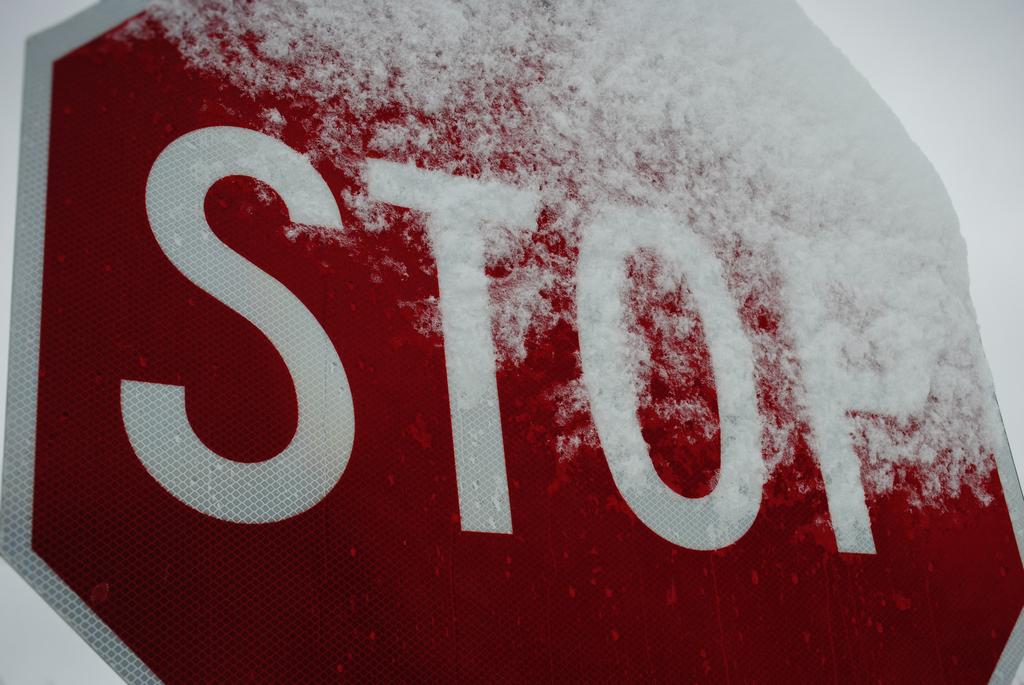What is this sign directing motorists to do?
Keep it short and to the point. Stop. 